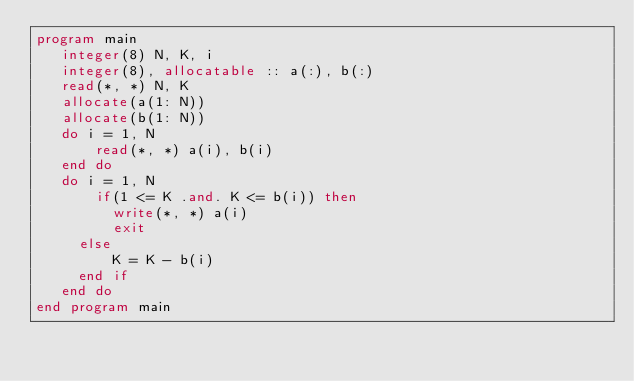<code> <loc_0><loc_0><loc_500><loc_500><_FORTRAN_>program main
   integer(8) N, K, i
   integer(8), allocatable :: a(:), b(:)
   read(*, *) N, K
   allocate(a(1: N))
   allocate(b(1: N))
   do i = 1, N
       read(*, *) a(i), b(i)
   end do
   do i = 1, N
       if(1 <= K .and. K <= b(i)) then
	       write(*, *) a(i)
	       exit
	   else
	       K = K - b(i)
	   end if
   end do
end program main</code> 